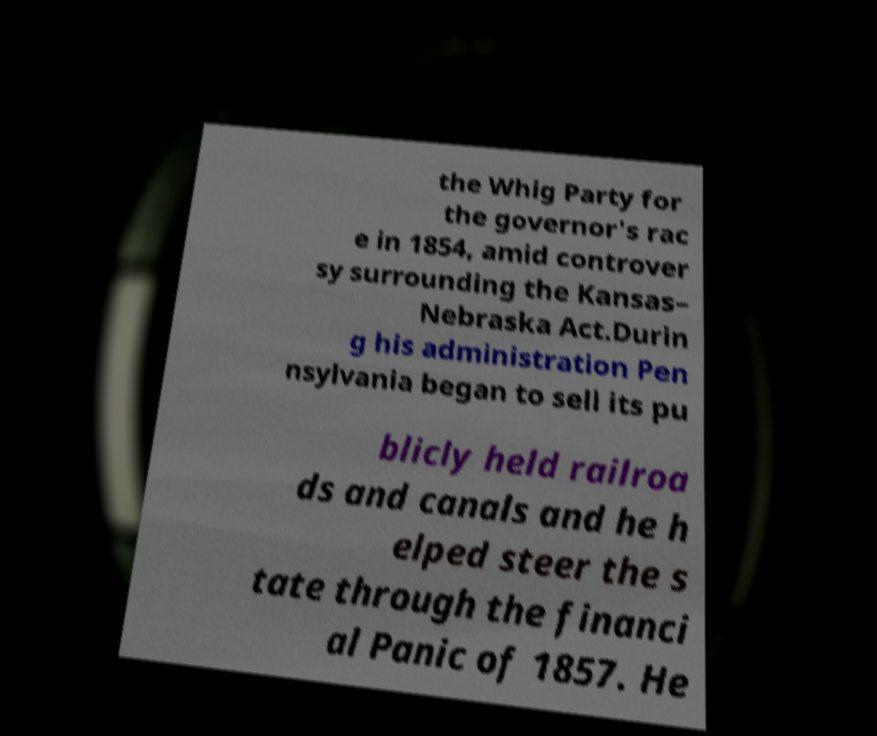For documentation purposes, I need the text within this image transcribed. Could you provide that? the Whig Party for the governor's rac e in 1854, amid controver sy surrounding the Kansas– Nebraska Act.Durin g his administration Pen nsylvania began to sell its pu blicly held railroa ds and canals and he h elped steer the s tate through the financi al Panic of 1857. He 